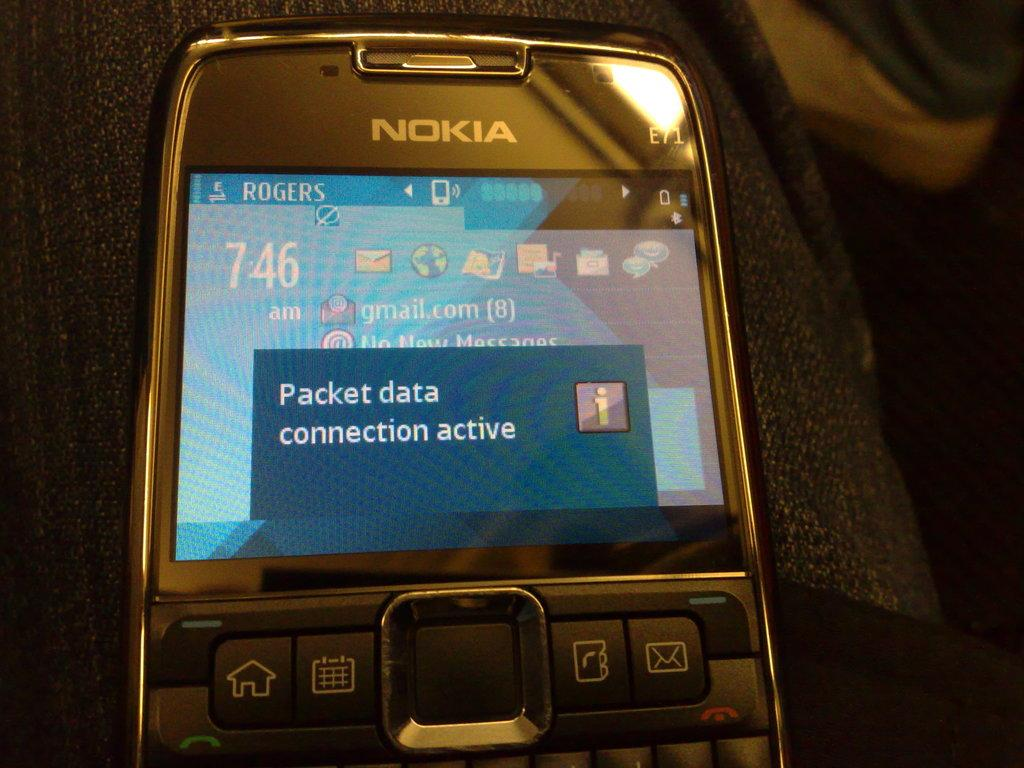What type of mobile is visible in the image? There is a Nokia mobile in the image. What information is displayed on the mobile's screen? The display of the mobile says "packet data connection active." What type of animal is sitting on the mobile in the image? There is no animal present in the image; it only shows a Nokia mobile with a display message. 